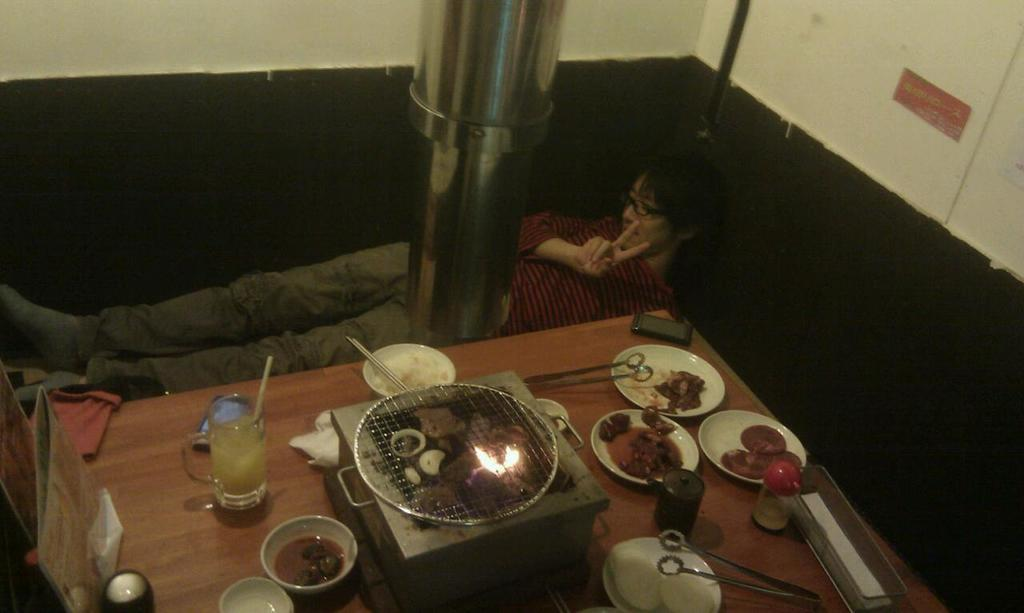What is the main subject of the image? There is a person sleeping in the image. What can be seen on the person's face? The person is wearing spectacles. What else is visible in the image besides the sleeping person? There are food items on a dining table in the image. What type of tank can be seen in the image? There is no tank present in the image. What kind of approval is the person seeking in the image? The person is sleeping, so they are not seeking any approval in the image. 